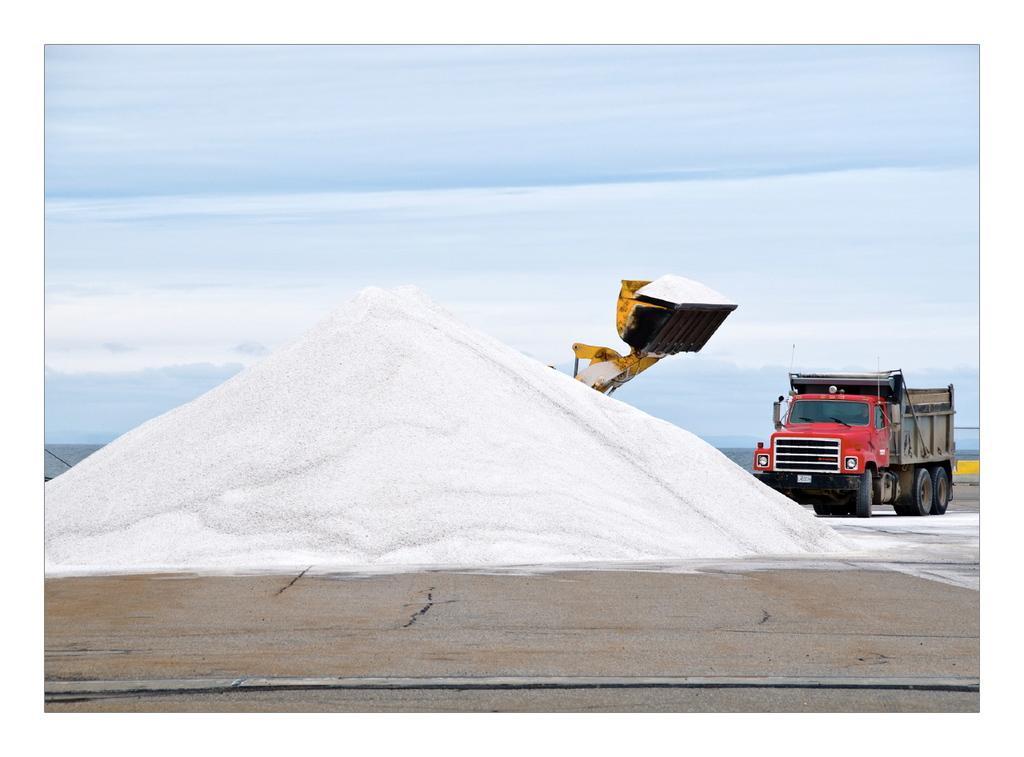Please provide a concise description of this image. In this image we can see a material which is in white color. Right side of the image one lorry is there and one vehicle is present. The sky is in blue color with some clouds. 